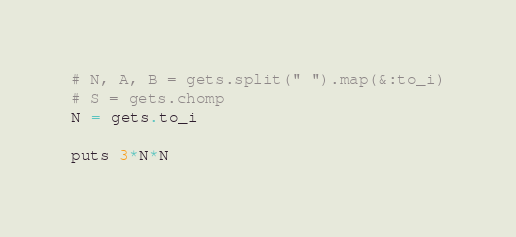Convert code to text. <code><loc_0><loc_0><loc_500><loc_500><_Ruby_># N, A, B = gets.split(" ").map(&:to_i)
# S = gets.chomp
N = gets.to_i

puts 3*N*N</code> 